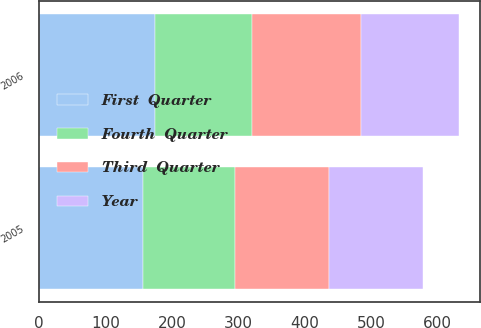<chart> <loc_0><loc_0><loc_500><loc_500><stacked_bar_chart><ecel><fcel>2006<fcel>2005<nl><fcel>Third  Quarter<fcel>165<fcel>142<nl><fcel>Year<fcel>147<fcel>141<nl><fcel>Fourth  Quarter<fcel>146<fcel>139<nl><fcel>First  Quarter<fcel>174<fcel>156<nl></chart> 